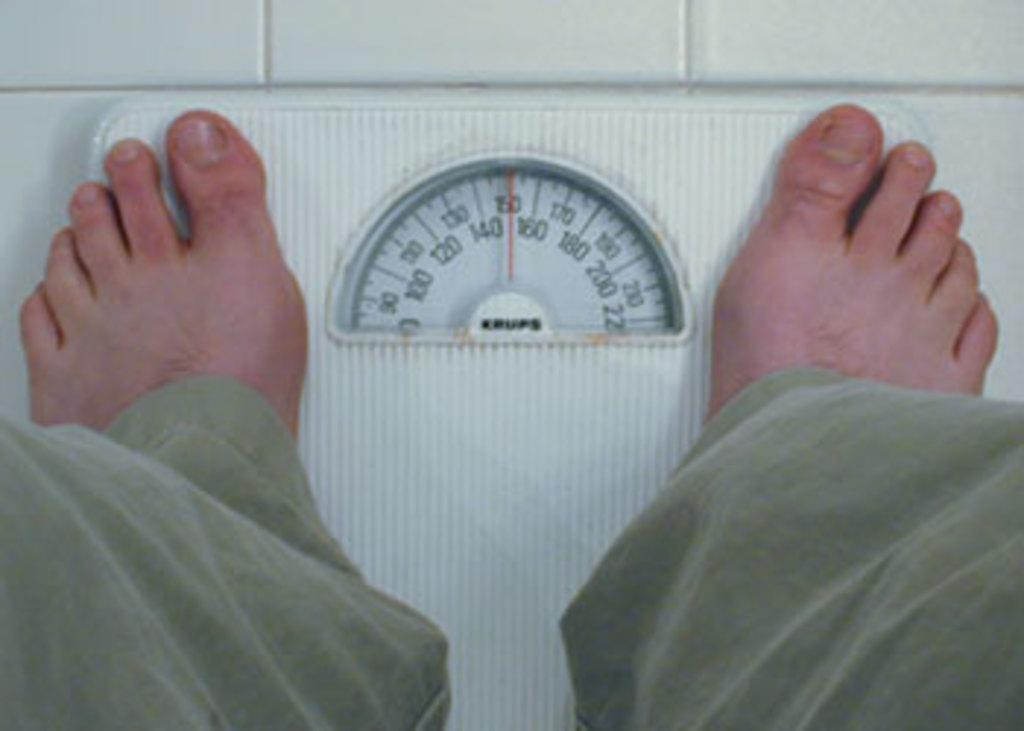What type of equipment is in the image? There is a weight machine in the image. Where is the weight machine located? The weight machine is on the floor. What feature does the weight machine have? The weight machine has a meter and readings forings. Who is present in the image? There is a person in the image. What part of the person's body is in contact with the weight machine? The person's feet are on the weight machine. What type of ocean waves can be seen in the image? There is no ocean or waves present in the image; it features a weight machine and a person using it. 